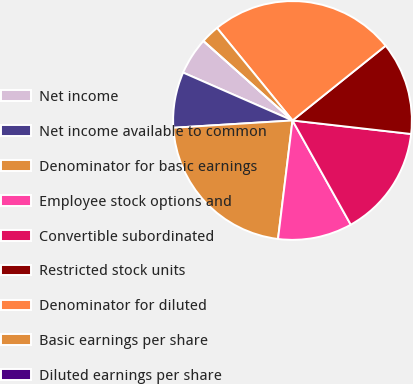Convert chart to OTSL. <chart><loc_0><loc_0><loc_500><loc_500><pie_chart><fcel>Net income<fcel>Net income available to common<fcel>Denominator for basic earnings<fcel>Employee stock options and<fcel>Convertible subordinated<fcel>Restricted stock units<fcel>Denominator for diluted<fcel>Basic earnings per share<fcel>Diluted earnings per share<nl><fcel>5.03%<fcel>7.54%<fcel>22.09%<fcel>10.05%<fcel>15.08%<fcel>12.57%<fcel>25.13%<fcel>2.51%<fcel>0.0%<nl></chart> 